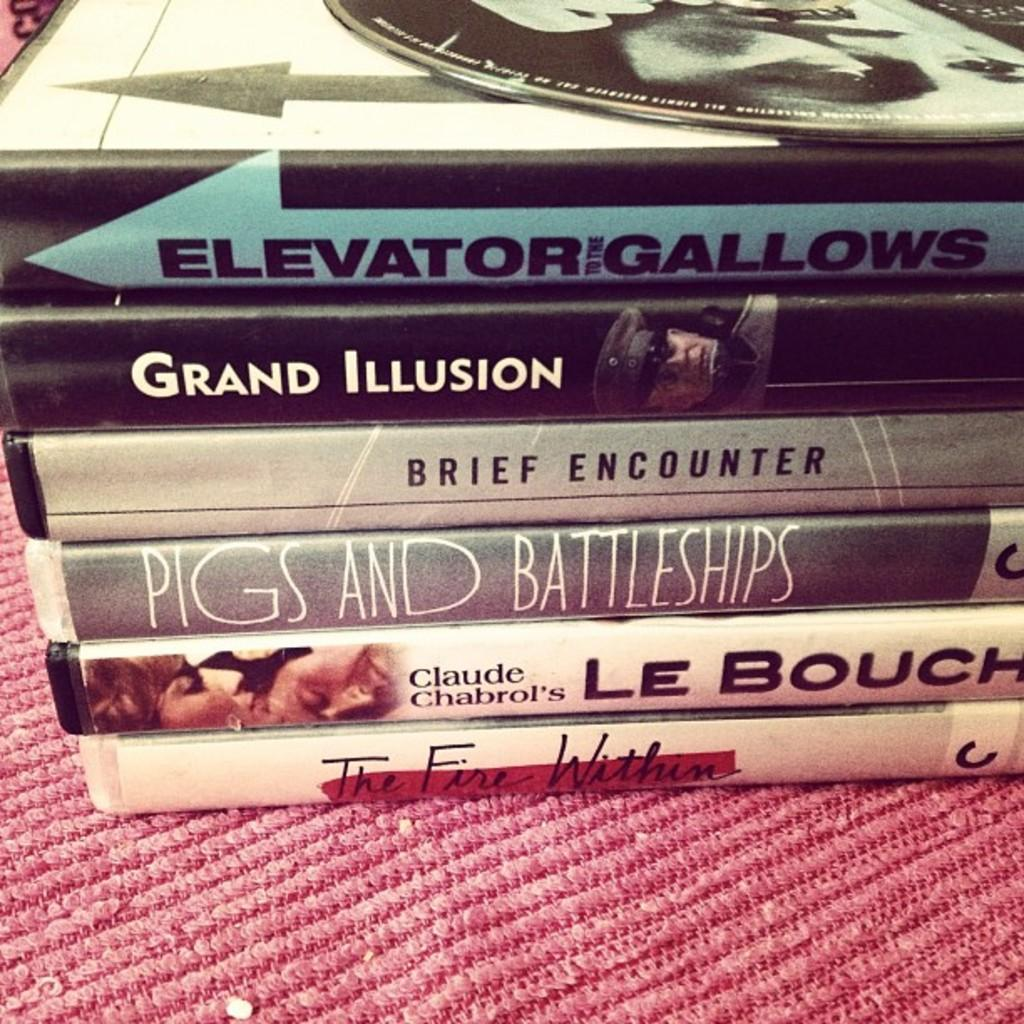<image>
Create a compact narrative representing the image presented. A stack of several DVDs with one in the middle being Pigs and Battleships. 